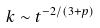<formula> <loc_0><loc_0><loc_500><loc_500>k \sim t ^ { - 2 / ( 3 + p ) }</formula> 